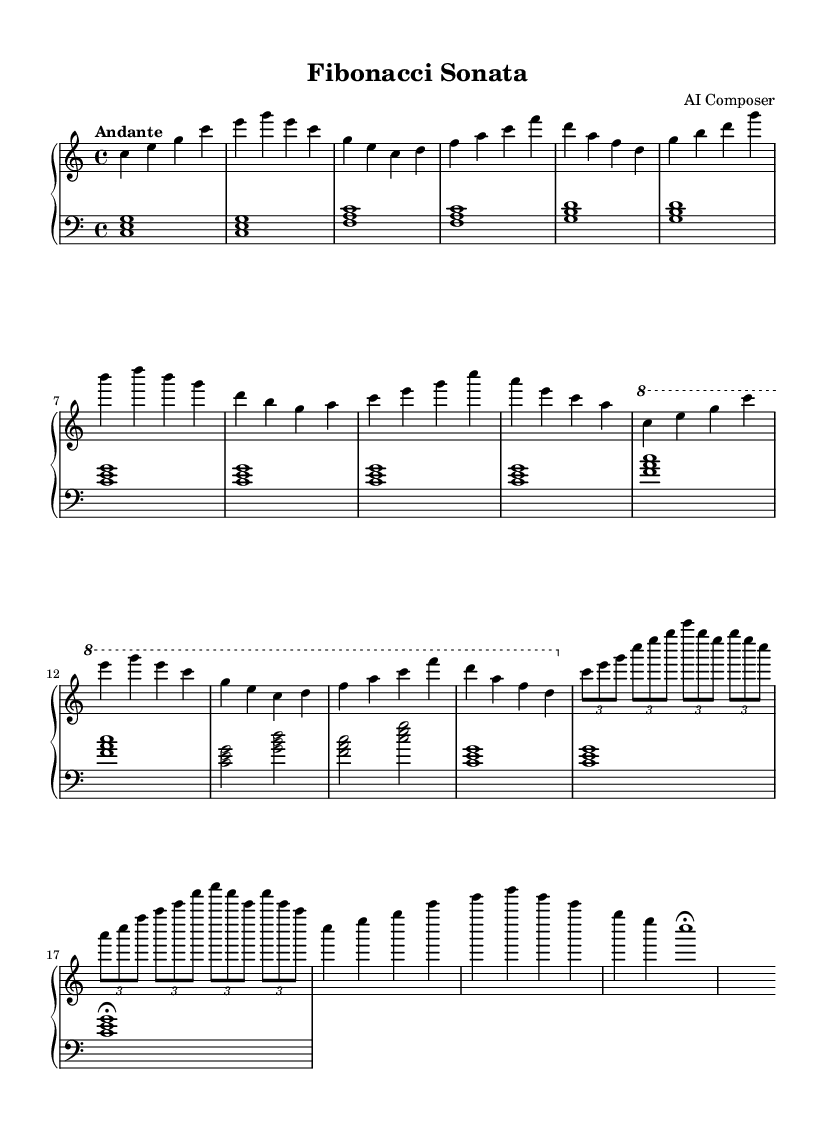What is the key signature of this music? The key signature is located at the beginning of the piece, showing no sharps or flats, indicating C major.
Answer: C major What is the time signature of this composition? The time signature is found at the start of the piece, showing 4/4, which means there are four beats in each measure.
Answer: 4/4 What is the tempo marking for this piece? The tempo marking is indicated near the beginning and states "Andante," which means a moderate walking pace.
Answer: Andante How many sections does this piece have? The piece is structured into five main sections: Introduction, Theme A, Theme B, Development, and Recapitulation.
Answer: Five In which section is the theme first introduced? The theme is first introduced in the "Theme A" section following the introduction.
Answer: Theme A How many times is the chord c e g played in the left hand during the "Introduction"? The chord c e g is played twice in the left hand during the "Introduction" section. This is observed in the first two measures.
Answer: Twice Which part of the sonata features tuplet notation? The tuplet notation appears in the "Development" section where multiple notes are grouped into a specified rhythmic value.
Answer: Development 